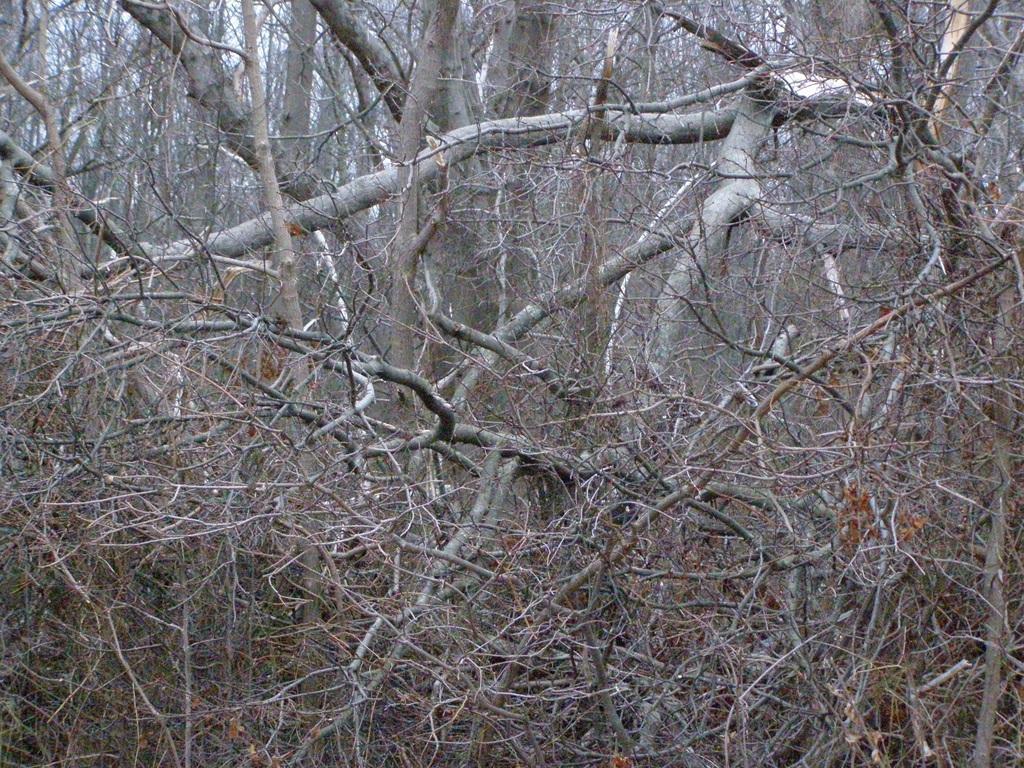Can you describe this image briefly? In this image I can see a fallen tree which is brown and grey in color and in the background I can see few trees and the sky. 